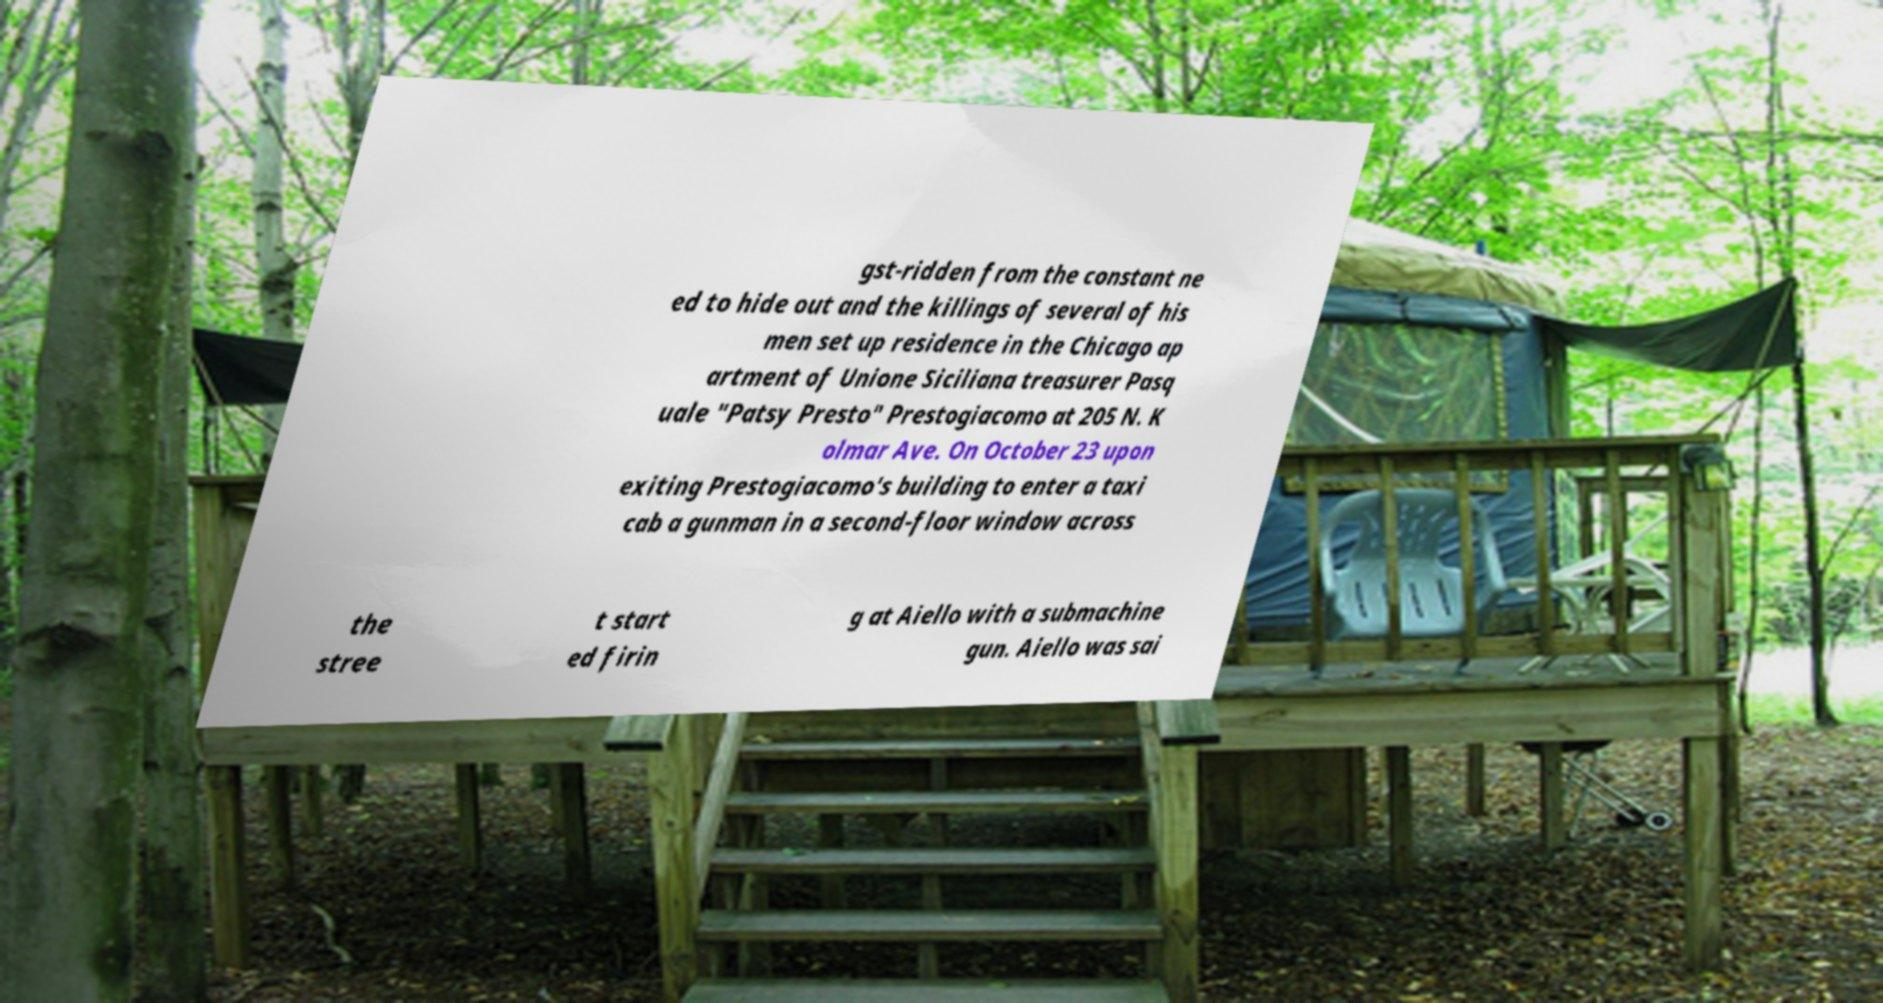For documentation purposes, I need the text within this image transcribed. Could you provide that? gst-ridden from the constant ne ed to hide out and the killings of several of his men set up residence in the Chicago ap artment of Unione Siciliana treasurer Pasq uale "Patsy Presto" Prestogiacomo at 205 N. K olmar Ave. On October 23 upon exiting Prestogiacomo's building to enter a taxi cab a gunman in a second-floor window across the stree t start ed firin g at Aiello with a submachine gun. Aiello was sai 